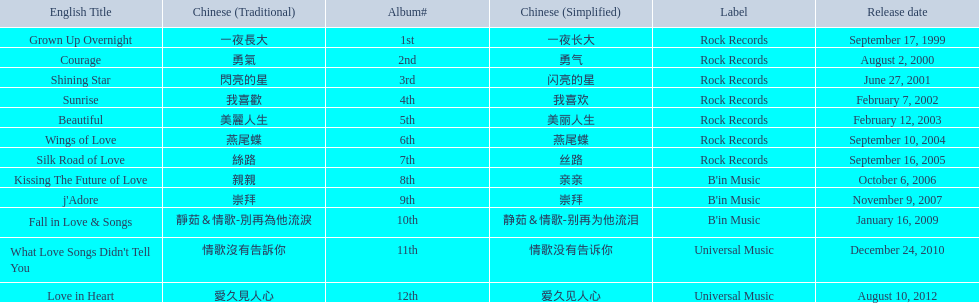What songs were on b'in music or universal music? Kissing The Future of Love, j'Adore, Fall in Love & Songs, What Love Songs Didn't Tell You, Love in Heart. 